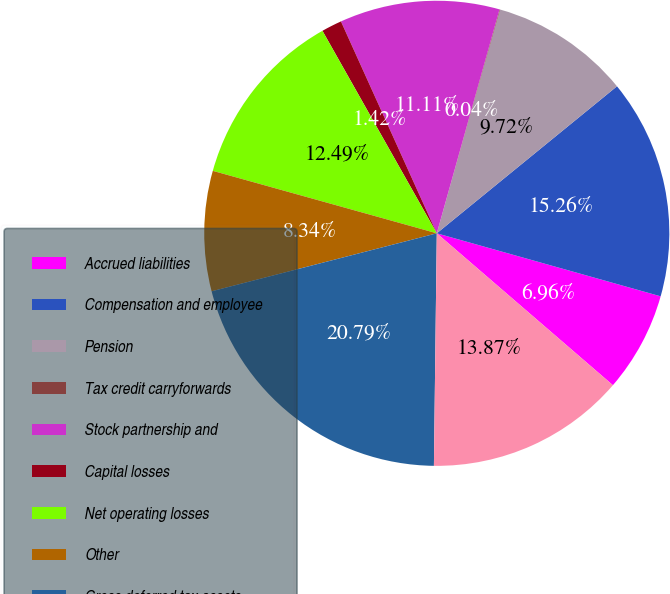Convert chart to OTSL. <chart><loc_0><loc_0><loc_500><loc_500><pie_chart><fcel>Accrued liabilities<fcel>Compensation and employee<fcel>Pension<fcel>Tax credit carryforwards<fcel>Stock partnership and<fcel>Capital losses<fcel>Net operating losses<fcel>Other<fcel>Gross deferred tax assets<fcel>Valuation allowance<nl><fcel>6.96%<fcel>15.26%<fcel>9.72%<fcel>0.04%<fcel>11.11%<fcel>1.42%<fcel>12.49%<fcel>8.34%<fcel>20.79%<fcel>13.87%<nl></chart> 